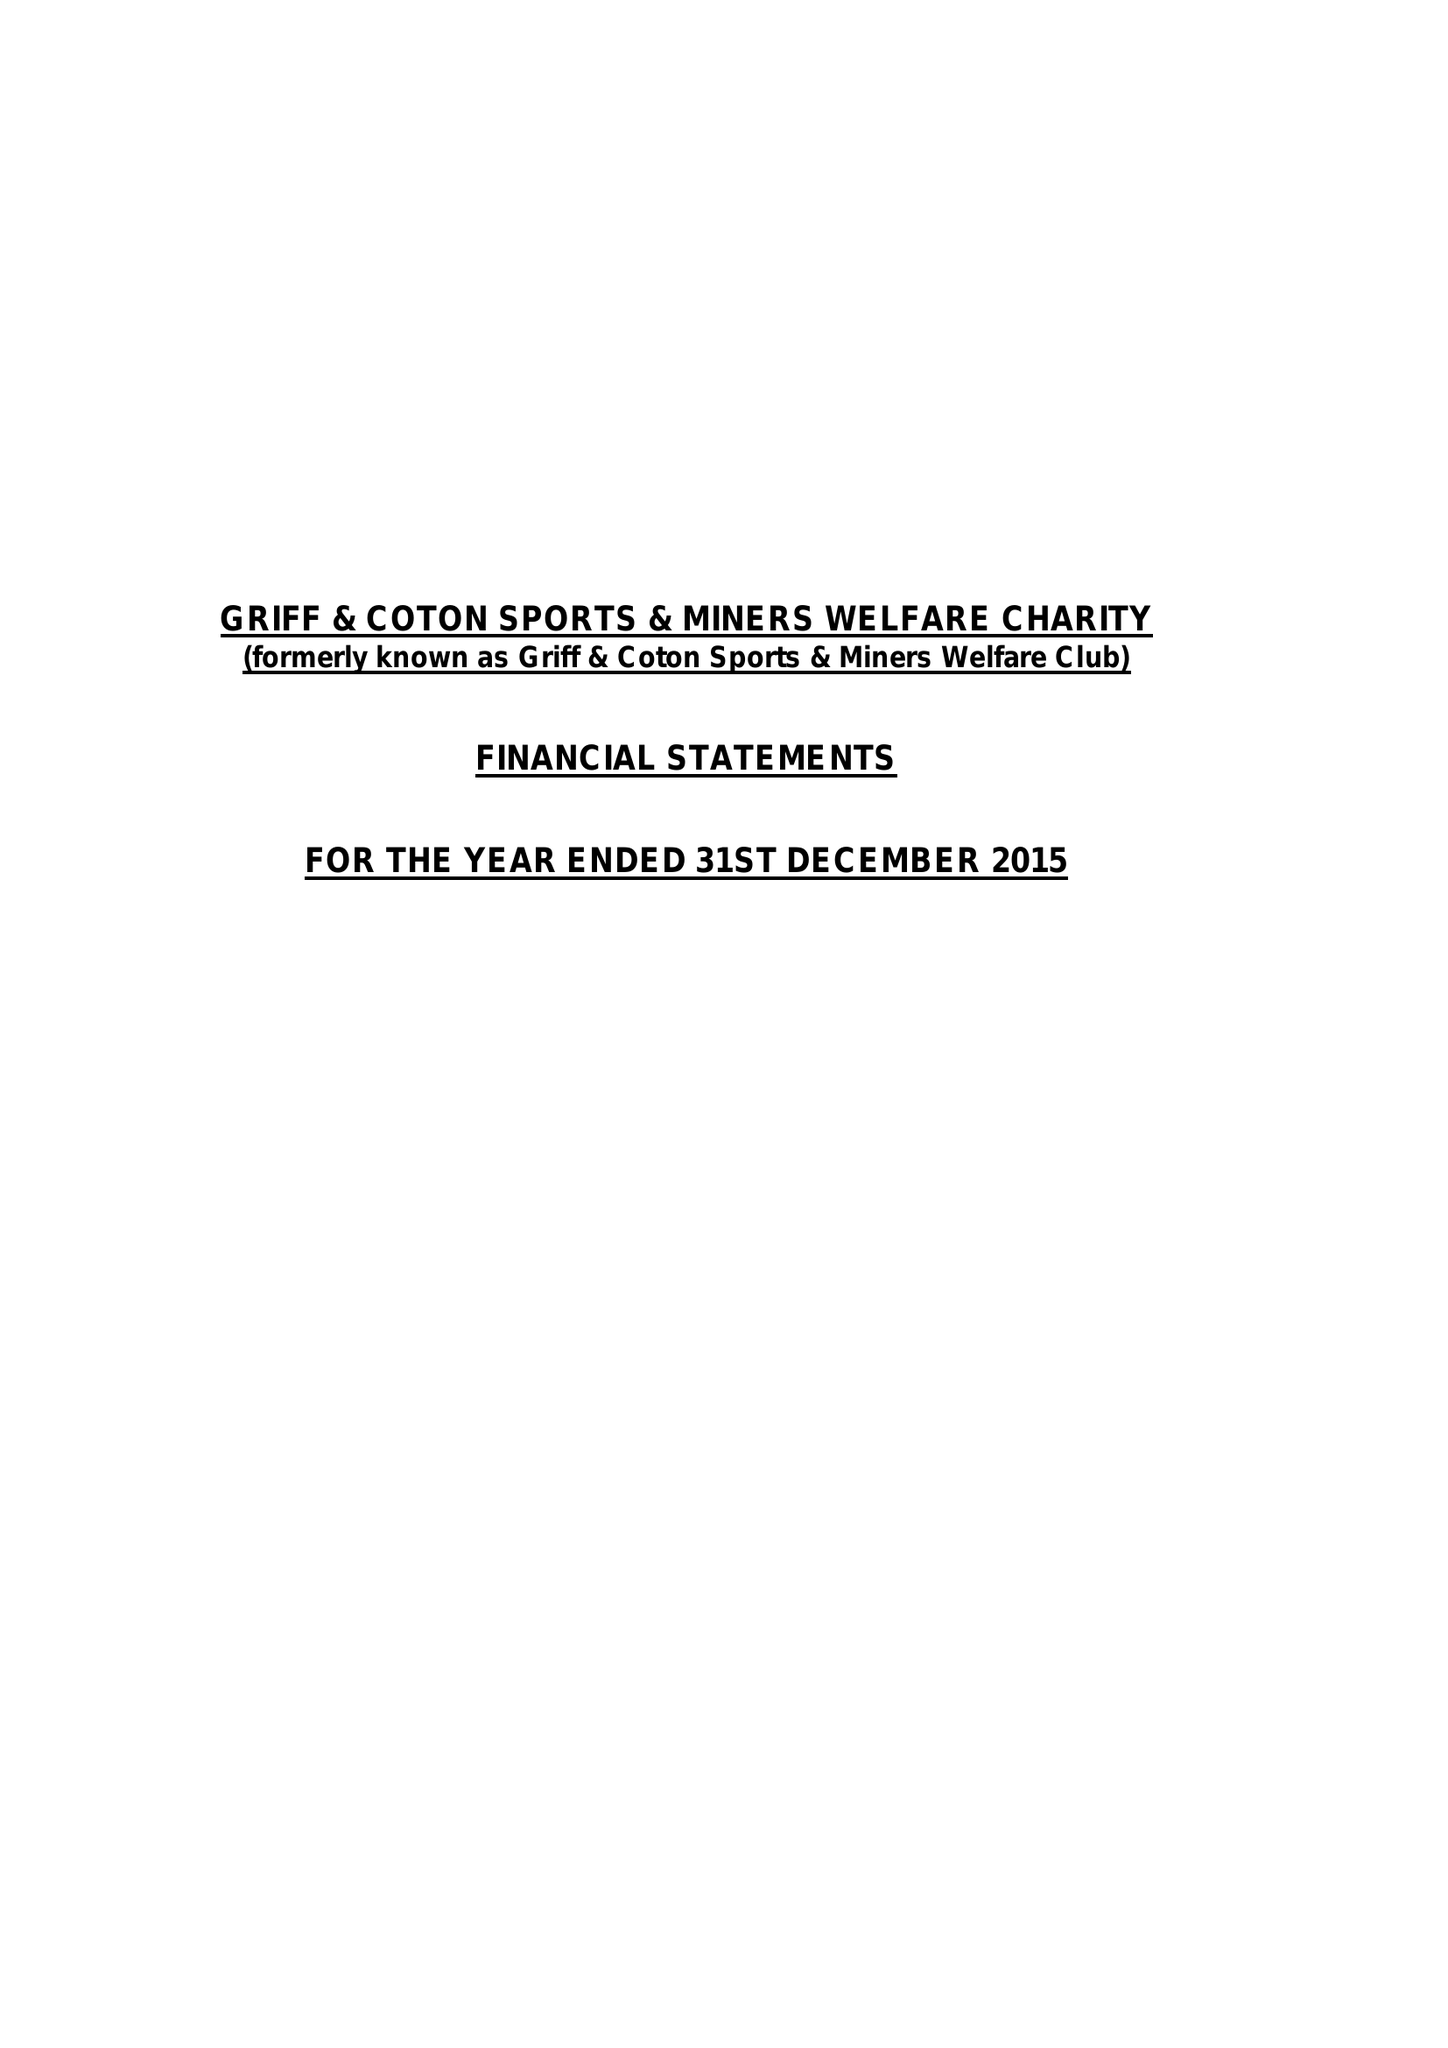What is the value for the address__postcode?
Answer the question using a single word or phrase. CV10 7JQ 